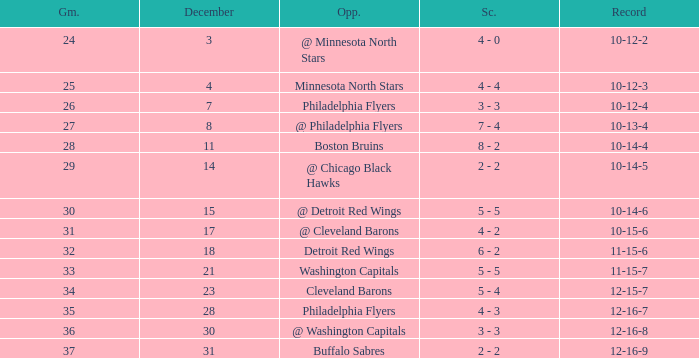What is the lowest December, when Score is "4 - 4"? 4.0. 